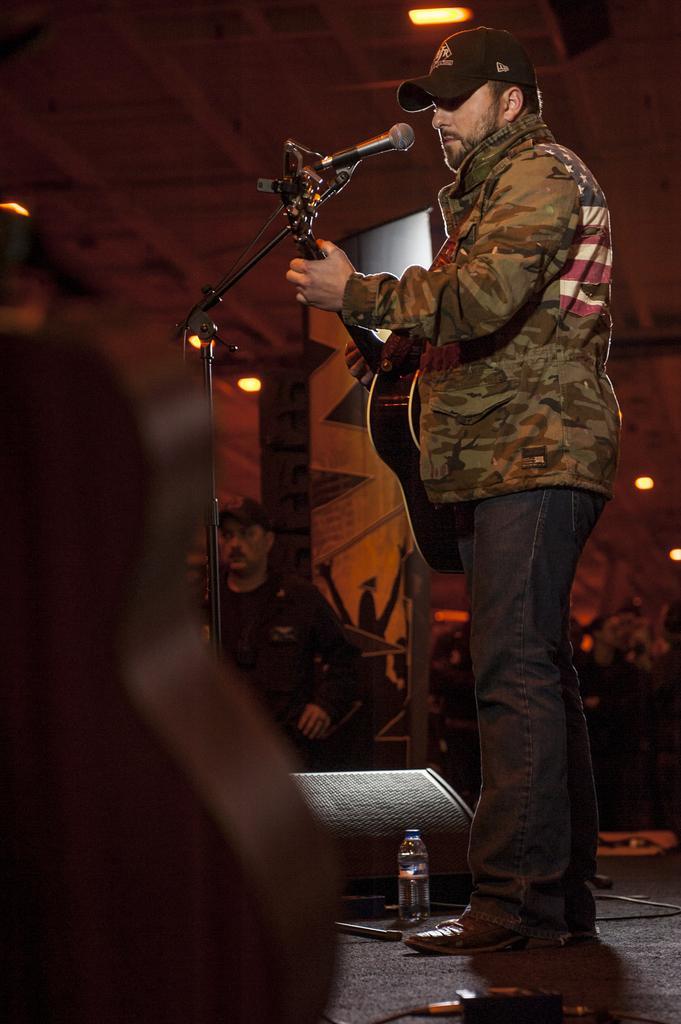Could you give a brief overview of what you see in this image? The person wearing black jeans is playing guitar in front of a mike there is also another wearing black shirt in the background. 